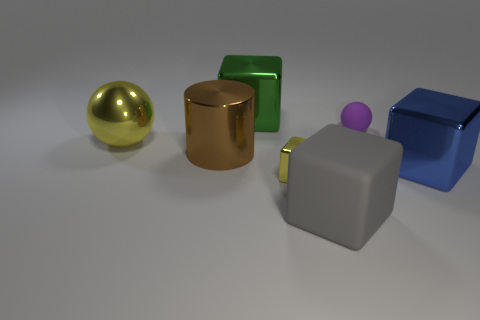There is a purple matte object that is the same shape as the large yellow metal thing; what is its size?
Your answer should be compact. Small. What number of matte things are purple things or small things?
Your response must be concise. 1. There is a large object on the right side of the ball that is right of the large cube that is behind the blue shiny block; what is its material?
Your answer should be very brief. Metal. There is a yellow object that is in front of the blue cube; is it the same shape as the matte thing that is in front of the tiny yellow metal object?
Give a very brief answer. Yes. What color is the metal cube in front of the big metal thing on the right side of the small ball?
Your response must be concise. Yellow. How many cylinders are either gray things or tiny purple matte objects?
Give a very brief answer. 0. How many blocks are behind the big thing behind the yellow object behind the blue metallic object?
Provide a short and direct response. 0. The metal block that is the same color as the big shiny sphere is what size?
Your response must be concise. Small. Is there a large ball that has the same material as the brown object?
Ensure brevity in your answer.  Yes. Are the blue object and the small yellow block made of the same material?
Offer a terse response. Yes. 